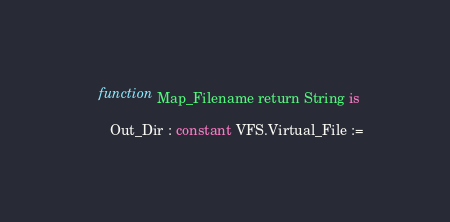Convert code to text. <code><loc_0><loc_0><loc_500><loc_500><_Ada_>   function Map_Filename return String is

      Out_Dir : constant VFS.Virtual_File :=</code> 